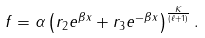Convert formula to latex. <formula><loc_0><loc_0><loc_500><loc_500>f = \alpha \left ( r _ { 2 } e ^ { \beta x } + r _ { 3 } e ^ { - \beta x } \right ) ^ { \frac { K } { ( \ell + 1 ) } } .</formula> 